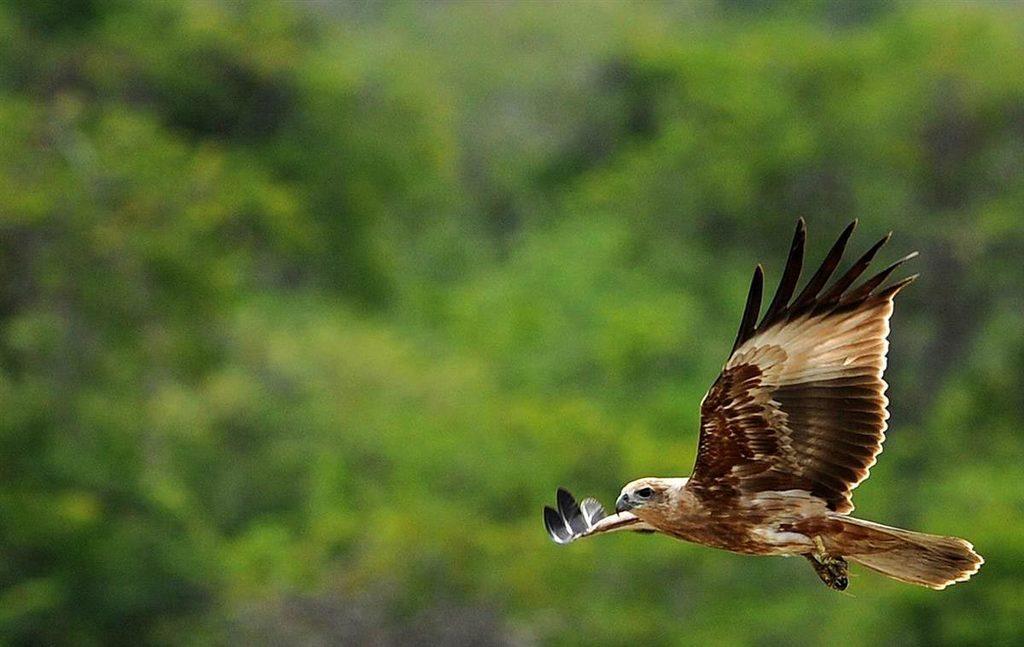How would you summarize this image in a sentence or two? In the picture we can see an eagle which is flying and in the background picture is blur. 